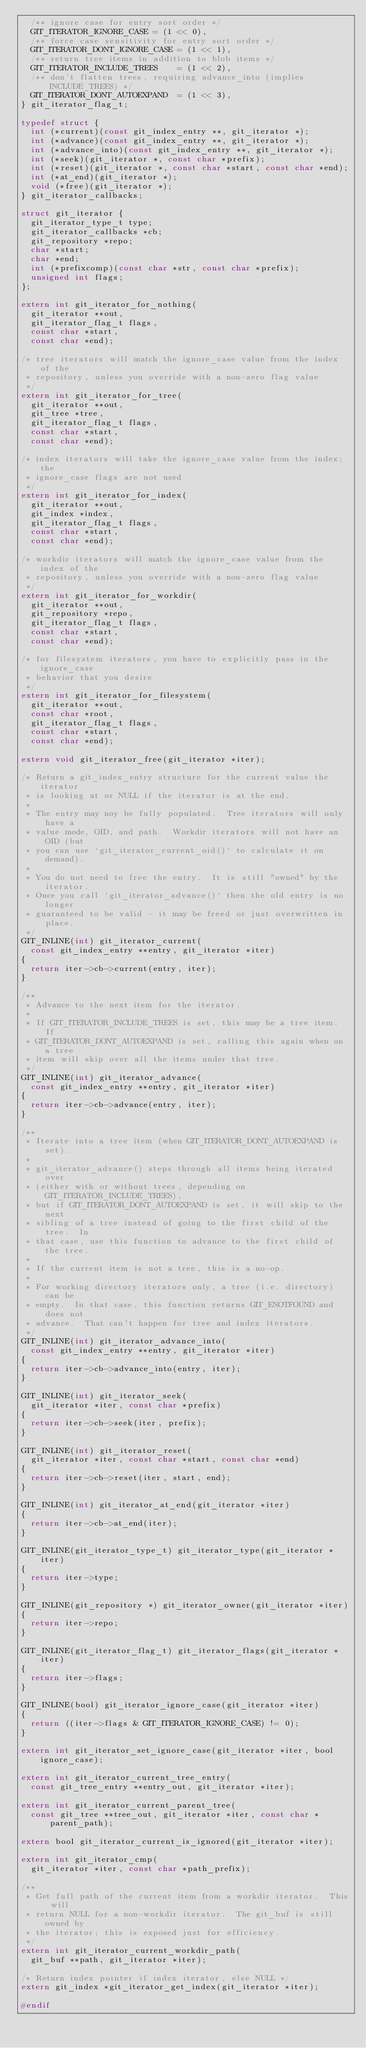Convert code to text. <code><loc_0><loc_0><loc_500><loc_500><_C_>	/** ignore case for entry sort order */
	GIT_ITERATOR_IGNORE_CASE = (1 << 0),
	/** force case sensitivity for entry sort order */
	GIT_ITERATOR_DONT_IGNORE_CASE = (1 << 1),
	/** return tree items in addition to blob items */
	GIT_ITERATOR_INCLUDE_TREES    = (1 << 2),
	/** don't flatten trees, requiring advance_into (implies INCLUDE_TREES) */
	GIT_ITERATOR_DONT_AUTOEXPAND  = (1 << 3),
} git_iterator_flag_t;

typedef struct {
	int (*current)(const git_index_entry **, git_iterator *);
	int (*advance)(const git_index_entry **, git_iterator *);
	int (*advance_into)(const git_index_entry **, git_iterator *);
	int (*seek)(git_iterator *, const char *prefix);
	int (*reset)(git_iterator *, const char *start, const char *end);
	int (*at_end)(git_iterator *);
	void (*free)(git_iterator *);
} git_iterator_callbacks;

struct git_iterator {
	git_iterator_type_t type;
	git_iterator_callbacks *cb;
	git_repository *repo;
	char *start;
	char *end;
	int (*prefixcomp)(const char *str, const char *prefix);
	unsigned int flags;
};

extern int git_iterator_for_nothing(
	git_iterator **out,
	git_iterator_flag_t flags,
	const char *start,
	const char *end);

/* tree iterators will match the ignore_case value from the index of the
 * repository, unless you override with a non-zero flag value
 */
extern int git_iterator_for_tree(
	git_iterator **out,
	git_tree *tree,
	git_iterator_flag_t flags,
	const char *start,
	const char *end);

/* index iterators will take the ignore_case value from the index; the
 * ignore_case flags are not used
 */
extern int git_iterator_for_index(
	git_iterator **out,
	git_index *index,
	git_iterator_flag_t flags,
	const char *start,
	const char *end);

/* workdir iterators will match the ignore_case value from the index of the
 * repository, unless you override with a non-zero flag value
 */
extern int git_iterator_for_workdir(
	git_iterator **out,
	git_repository *repo,
	git_iterator_flag_t flags,
	const char *start,
	const char *end);

/* for filesystem iterators, you have to explicitly pass in the ignore_case
 * behavior that you desire
 */
extern int git_iterator_for_filesystem(
	git_iterator **out,
	const char *root,
	git_iterator_flag_t flags,
	const char *start,
	const char *end);

extern void git_iterator_free(git_iterator *iter);

/* Return a git_index_entry structure for the current value the iterator
 * is looking at or NULL if the iterator is at the end.
 *
 * The entry may noy be fully populated.  Tree iterators will only have a
 * value mode, OID, and path.  Workdir iterators will not have an OID (but
 * you can use `git_iterator_current_oid()` to calculate it on demand).
 *
 * You do not need to free the entry.  It is still "owned" by the iterator.
 * Once you call `git_iterator_advance()` then the old entry is no longer
 * guaranteed to be valid - it may be freed or just overwritten in place.
 */
GIT_INLINE(int) git_iterator_current(
	const git_index_entry **entry, git_iterator *iter)
{
	return iter->cb->current(entry, iter);
}

/**
 * Advance to the next item for the iterator.
 *
 * If GIT_ITERATOR_INCLUDE_TREES is set, this may be a tree item.  If
 * GIT_ITERATOR_DONT_AUTOEXPAND is set, calling this again when on a tree
 * item will skip over all the items under that tree.
 */
GIT_INLINE(int) git_iterator_advance(
	const git_index_entry **entry, git_iterator *iter)
{
	return iter->cb->advance(entry, iter);
}

/**
 * Iterate into a tree item (when GIT_ITERATOR_DONT_AUTOEXPAND is set).
 *
 * git_iterator_advance() steps through all items being iterated over
 * (either with or without trees, depending on GIT_ITERATOR_INCLUDE_TREES),
 * but if GIT_ITERATOR_DONT_AUTOEXPAND is set, it will skip to the next
 * sibling of a tree instead of going to the first child of the tree.  In
 * that case, use this function to advance to the first child of the tree.
 *
 * If the current item is not a tree, this is a no-op.
 *
 * For working directory iterators only, a tree (i.e. directory) can be
 * empty.  In that case, this function returns GIT_ENOTFOUND and does not
 * advance.  That can't happen for tree and index iterators.
 */
GIT_INLINE(int) git_iterator_advance_into(
	const git_index_entry **entry, git_iterator *iter)
{
	return iter->cb->advance_into(entry, iter);
}

GIT_INLINE(int) git_iterator_seek(
	git_iterator *iter, const char *prefix)
{
	return iter->cb->seek(iter, prefix);
}

GIT_INLINE(int) git_iterator_reset(
	git_iterator *iter, const char *start, const char *end)
{
	return iter->cb->reset(iter, start, end);
}

GIT_INLINE(int) git_iterator_at_end(git_iterator *iter)
{
	return iter->cb->at_end(iter);
}

GIT_INLINE(git_iterator_type_t) git_iterator_type(git_iterator *iter)
{
	return iter->type;
}

GIT_INLINE(git_repository *) git_iterator_owner(git_iterator *iter)
{
	return iter->repo;
}

GIT_INLINE(git_iterator_flag_t) git_iterator_flags(git_iterator *iter)
{
	return iter->flags;
}

GIT_INLINE(bool) git_iterator_ignore_case(git_iterator *iter)
{
	return ((iter->flags & GIT_ITERATOR_IGNORE_CASE) != 0);
}

extern int git_iterator_set_ignore_case(git_iterator *iter, bool ignore_case);

extern int git_iterator_current_tree_entry(
	const git_tree_entry **entry_out, git_iterator *iter);

extern int git_iterator_current_parent_tree(
	const git_tree **tree_out, git_iterator *iter, const char *parent_path);

extern bool git_iterator_current_is_ignored(git_iterator *iter);

extern int git_iterator_cmp(
	git_iterator *iter, const char *path_prefix);

/**
 * Get full path of the current item from a workdir iterator.  This will
 * return NULL for a non-workdir iterator.  The git_buf is still owned by
 * the iterator; this is exposed just for efficiency.
 */
extern int git_iterator_current_workdir_path(
	git_buf **path, git_iterator *iter);

/* Return index pointer if index iterator, else NULL */
extern git_index *git_iterator_get_index(git_iterator *iter);

#endif
</code> 